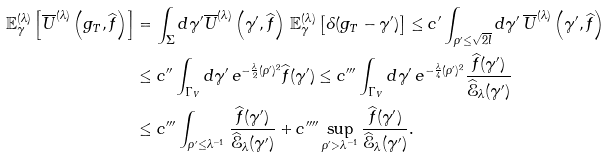<formula> <loc_0><loc_0><loc_500><loc_500>\mathbb { E } ^ { ( \lambda ) } _ { \gamma } \left [ \overline { U } ^ { ( \lambda ) } \left ( g _ { T } , \widehat { f } \right ) \right ] & = \int _ { \Sigma } d \gamma ^ { \prime } \overline { U } ^ { ( \lambda ) } \left ( \gamma ^ { \prime } , \widehat { f } \right ) \, \mathbb { E } ^ { ( \lambda ) } _ { \gamma } \left [ \delta ( g _ { T } - \gamma ^ { \prime } ) \right ] \leq c ^ { \prime } \int _ { \rho ^ { \prime } \leq \sqrt { 2 l } } d \gamma ^ { \prime } \, \overline { U } ^ { ( \lambda ) } \left ( \gamma ^ { \prime } , \widehat { f } \right ) \\ & \leq c ^ { \prime \prime } \int _ { \Gamma _ { V } } d \gamma ^ { \prime } \, e ^ { - \frac { \lambda } { 2 } ( \rho ^ { \prime } ) ^ { 2 } } \widehat { f } ( \gamma ^ { \prime } ) \leq c ^ { \prime \prime \prime } \int _ { \Gamma _ { V } } d \gamma ^ { \prime } \, e ^ { - \frac { \lambda } { 4 } ( \rho ^ { \prime } ) ^ { 2 } } \frac { \widehat { f } ( \gamma ^ { \prime } ) } { \widehat { \mathcal { E } } _ { \lambda } ( \gamma ^ { \prime } ) } \\ & \leq c ^ { \prime \prime \prime } \int _ { \rho ^ { \prime } \leq \lambda ^ { - 1 } } \frac { \widehat { f } ( \gamma ^ { \prime } ) } { \widehat { \mathcal { E } } _ { \lambda } ( \gamma ^ { \prime } ) } + c ^ { \prime \prime \prime \prime } \sup _ { \rho ^ { \prime } > \lambda ^ { - 1 } } \frac { \widehat { f } ( \gamma ^ { \prime } ) } { \widehat { \mathcal { E } } _ { \lambda } ( \gamma ^ { \prime } ) } .</formula> 